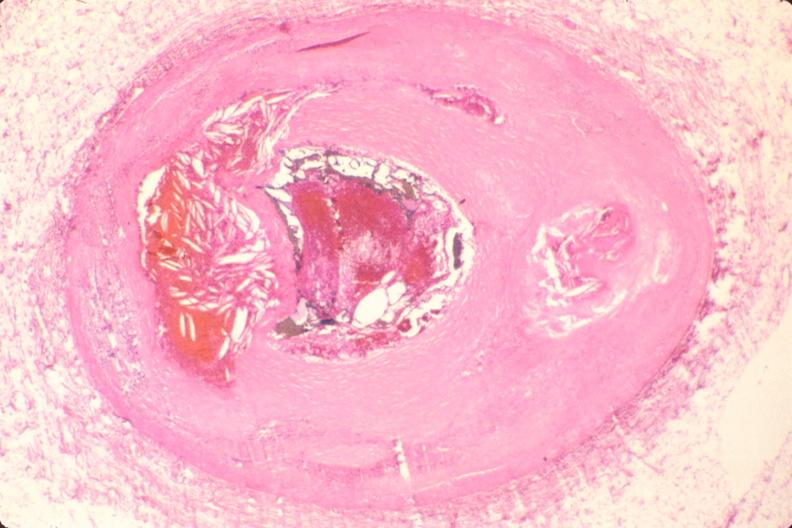what is present?
Answer the question using a single word or phrase. Cardiovascular 